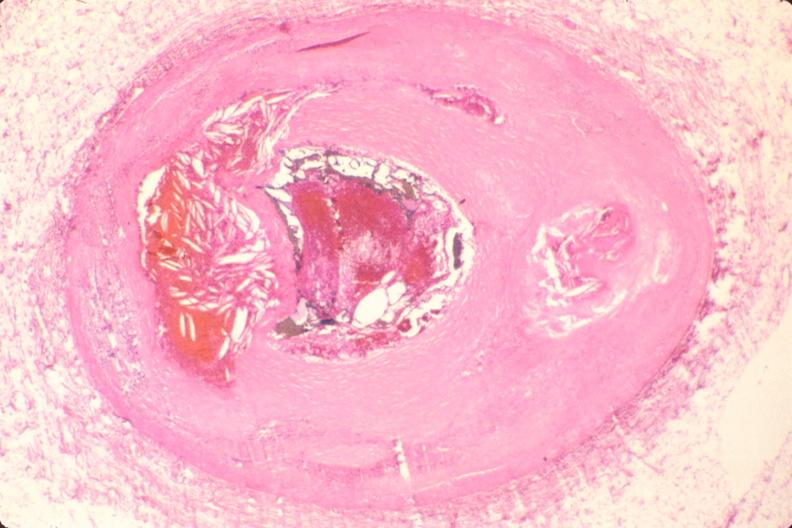what is present?
Answer the question using a single word or phrase. Cardiovascular 